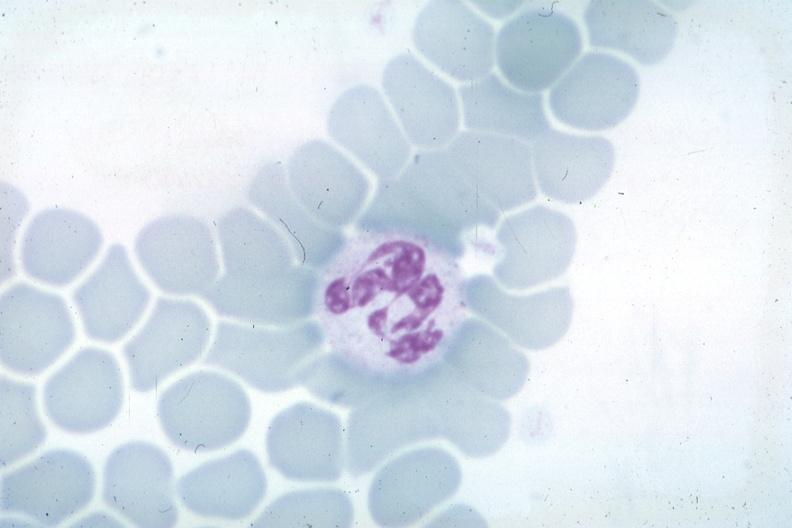s endocrine present?
Answer the question using a single word or phrase. No 